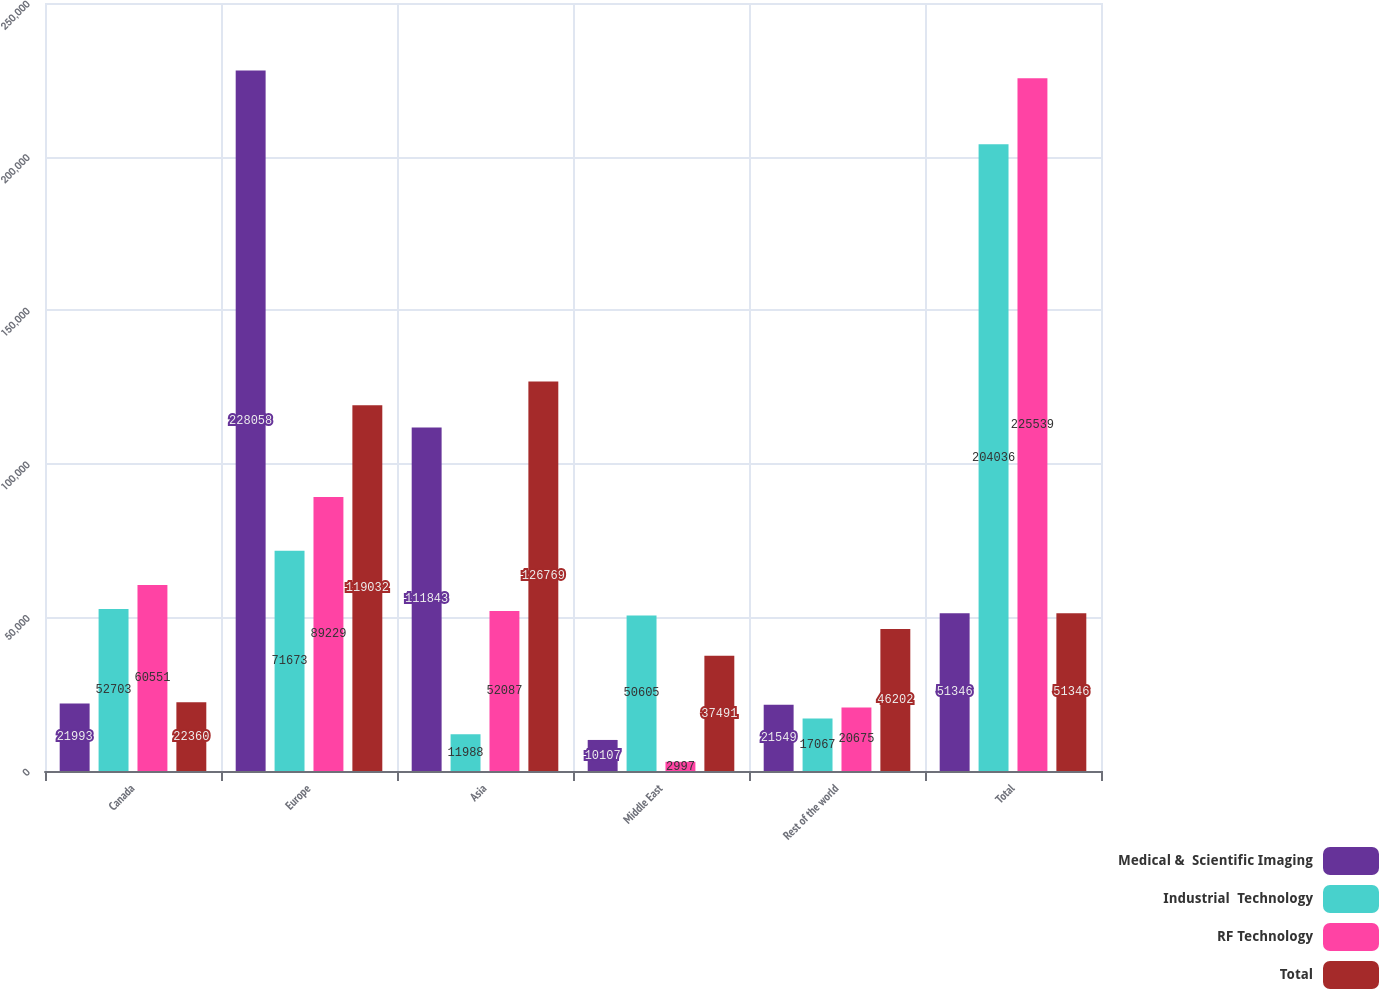Convert chart to OTSL. <chart><loc_0><loc_0><loc_500><loc_500><stacked_bar_chart><ecel><fcel>Canada<fcel>Europe<fcel>Asia<fcel>Middle East<fcel>Rest of the world<fcel>Total<nl><fcel>Medical &  Scientific Imaging<fcel>21993<fcel>228058<fcel>111843<fcel>10107<fcel>21549<fcel>51346<nl><fcel>Industrial  Technology<fcel>52703<fcel>71673<fcel>11988<fcel>50605<fcel>17067<fcel>204036<nl><fcel>RF Technology<fcel>60551<fcel>89229<fcel>52087<fcel>2997<fcel>20675<fcel>225539<nl><fcel>Total<fcel>22360<fcel>119032<fcel>126769<fcel>37491<fcel>46202<fcel>51346<nl></chart> 